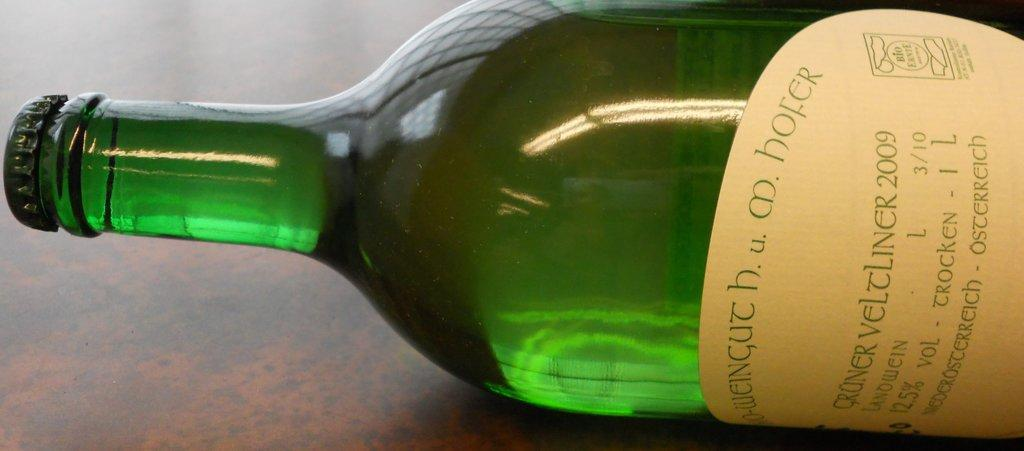<image>
Provide a brief description of the given image. A green bottle with a yellow label that says Cruner Veltliner 2009 is laying on its side. 